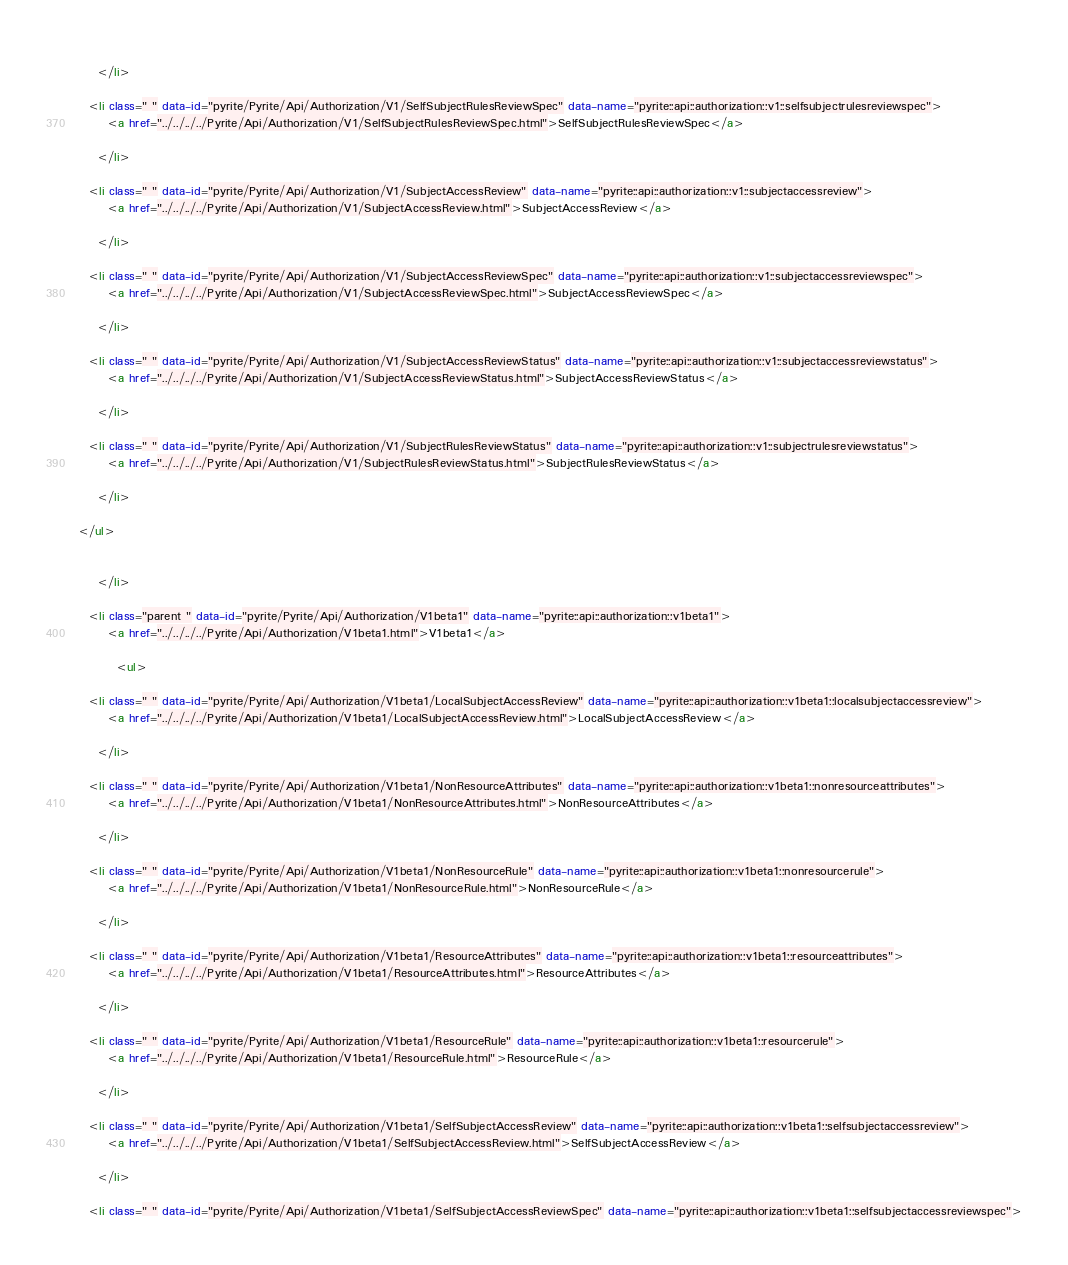Convert code to text. <code><loc_0><loc_0><loc_500><loc_500><_HTML_>      
    </li>
  
  <li class=" " data-id="pyrite/Pyrite/Api/Authorization/V1/SelfSubjectRulesReviewSpec" data-name="pyrite::api::authorization::v1::selfsubjectrulesreviewspec">
      <a href="../../../../Pyrite/Api/Authorization/V1/SelfSubjectRulesReviewSpec.html">SelfSubjectRulesReviewSpec</a>
      
    </li>
  
  <li class=" " data-id="pyrite/Pyrite/Api/Authorization/V1/SubjectAccessReview" data-name="pyrite::api::authorization::v1::subjectaccessreview">
      <a href="../../../../Pyrite/Api/Authorization/V1/SubjectAccessReview.html">SubjectAccessReview</a>
      
    </li>
  
  <li class=" " data-id="pyrite/Pyrite/Api/Authorization/V1/SubjectAccessReviewSpec" data-name="pyrite::api::authorization::v1::subjectaccessreviewspec">
      <a href="../../../../Pyrite/Api/Authorization/V1/SubjectAccessReviewSpec.html">SubjectAccessReviewSpec</a>
      
    </li>
  
  <li class=" " data-id="pyrite/Pyrite/Api/Authorization/V1/SubjectAccessReviewStatus" data-name="pyrite::api::authorization::v1::subjectaccessreviewstatus">
      <a href="../../../../Pyrite/Api/Authorization/V1/SubjectAccessReviewStatus.html">SubjectAccessReviewStatus</a>
      
    </li>
  
  <li class=" " data-id="pyrite/Pyrite/Api/Authorization/V1/SubjectRulesReviewStatus" data-name="pyrite::api::authorization::v1::subjectrulesreviewstatus">
      <a href="../../../../Pyrite/Api/Authorization/V1/SubjectRulesReviewStatus.html">SubjectRulesReviewStatus</a>
      
    </li>
  
</ul>

      
    </li>
  
  <li class="parent " data-id="pyrite/Pyrite/Api/Authorization/V1beta1" data-name="pyrite::api::authorization::v1beta1">
      <a href="../../../../Pyrite/Api/Authorization/V1beta1.html">V1beta1</a>
      
        <ul>
  
  <li class=" " data-id="pyrite/Pyrite/Api/Authorization/V1beta1/LocalSubjectAccessReview" data-name="pyrite::api::authorization::v1beta1::localsubjectaccessreview">
      <a href="../../../../Pyrite/Api/Authorization/V1beta1/LocalSubjectAccessReview.html">LocalSubjectAccessReview</a>
      
    </li>
  
  <li class=" " data-id="pyrite/Pyrite/Api/Authorization/V1beta1/NonResourceAttributes" data-name="pyrite::api::authorization::v1beta1::nonresourceattributes">
      <a href="../../../../Pyrite/Api/Authorization/V1beta1/NonResourceAttributes.html">NonResourceAttributes</a>
      
    </li>
  
  <li class=" " data-id="pyrite/Pyrite/Api/Authorization/V1beta1/NonResourceRule" data-name="pyrite::api::authorization::v1beta1::nonresourcerule">
      <a href="../../../../Pyrite/Api/Authorization/V1beta1/NonResourceRule.html">NonResourceRule</a>
      
    </li>
  
  <li class=" " data-id="pyrite/Pyrite/Api/Authorization/V1beta1/ResourceAttributes" data-name="pyrite::api::authorization::v1beta1::resourceattributes">
      <a href="../../../../Pyrite/Api/Authorization/V1beta1/ResourceAttributes.html">ResourceAttributes</a>
      
    </li>
  
  <li class=" " data-id="pyrite/Pyrite/Api/Authorization/V1beta1/ResourceRule" data-name="pyrite::api::authorization::v1beta1::resourcerule">
      <a href="../../../../Pyrite/Api/Authorization/V1beta1/ResourceRule.html">ResourceRule</a>
      
    </li>
  
  <li class=" " data-id="pyrite/Pyrite/Api/Authorization/V1beta1/SelfSubjectAccessReview" data-name="pyrite::api::authorization::v1beta1::selfsubjectaccessreview">
      <a href="../../../../Pyrite/Api/Authorization/V1beta1/SelfSubjectAccessReview.html">SelfSubjectAccessReview</a>
      
    </li>
  
  <li class=" " data-id="pyrite/Pyrite/Api/Authorization/V1beta1/SelfSubjectAccessReviewSpec" data-name="pyrite::api::authorization::v1beta1::selfsubjectaccessreviewspec"></code> 